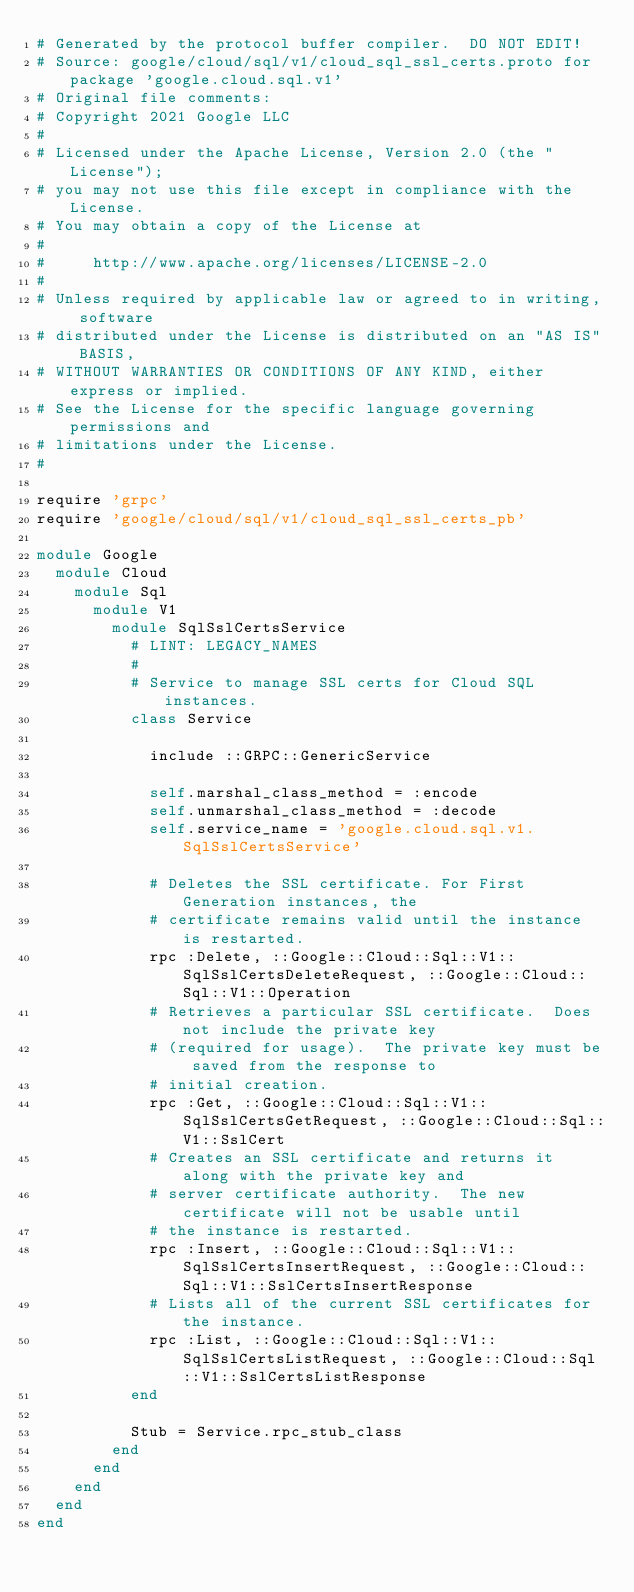<code> <loc_0><loc_0><loc_500><loc_500><_Ruby_># Generated by the protocol buffer compiler.  DO NOT EDIT!
# Source: google/cloud/sql/v1/cloud_sql_ssl_certs.proto for package 'google.cloud.sql.v1'
# Original file comments:
# Copyright 2021 Google LLC
#
# Licensed under the Apache License, Version 2.0 (the "License");
# you may not use this file except in compliance with the License.
# You may obtain a copy of the License at
#
#     http://www.apache.org/licenses/LICENSE-2.0
#
# Unless required by applicable law or agreed to in writing, software
# distributed under the License is distributed on an "AS IS" BASIS,
# WITHOUT WARRANTIES OR CONDITIONS OF ANY KIND, either express or implied.
# See the License for the specific language governing permissions and
# limitations under the License.
#

require 'grpc'
require 'google/cloud/sql/v1/cloud_sql_ssl_certs_pb'

module Google
  module Cloud
    module Sql
      module V1
        module SqlSslCertsService
          # LINT: LEGACY_NAMES
          #
          # Service to manage SSL certs for Cloud SQL instances.
          class Service

            include ::GRPC::GenericService

            self.marshal_class_method = :encode
            self.unmarshal_class_method = :decode
            self.service_name = 'google.cloud.sql.v1.SqlSslCertsService'

            # Deletes the SSL certificate. For First Generation instances, the
            # certificate remains valid until the instance is restarted.
            rpc :Delete, ::Google::Cloud::Sql::V1::SqlSslCertsDeleteRequest, ::Google::Cloud::Sql::V1::Operation
            # Retrieves a particular SSL certificate.  Does not include the private key
            # (required for usage).  The private key must be saved from the response to
            # initial creation.
            rpc :Get, ::Google::Cloud::Sql::V1::SqlSslCertsGetRequest, ::Google::Cloud::Sql::V1::SslCert
            # Creates an SSL certificate and returns it along with the private key and
            # server certificate authority.  The new certificate will not be usable until
            # the instance is restarted.
            rpc :Insert, ::Google::Cloud::Sql::V1::SqlSslCertsInsertRequest, ::Google::Cloud::Sql::V1::SslCertsInsertResponse
            # Lists all of the current SSL certificates for the instance.
            rpc :List, ::Google::Cloud::Sql::V1::SqlSslCertsListRequest, ::Google::Cloud::Sql::V1::SslCertsListResponse
          end

          Stub = Service.rpc_stub_class
        end
      end
    end
  end
end
</code> 